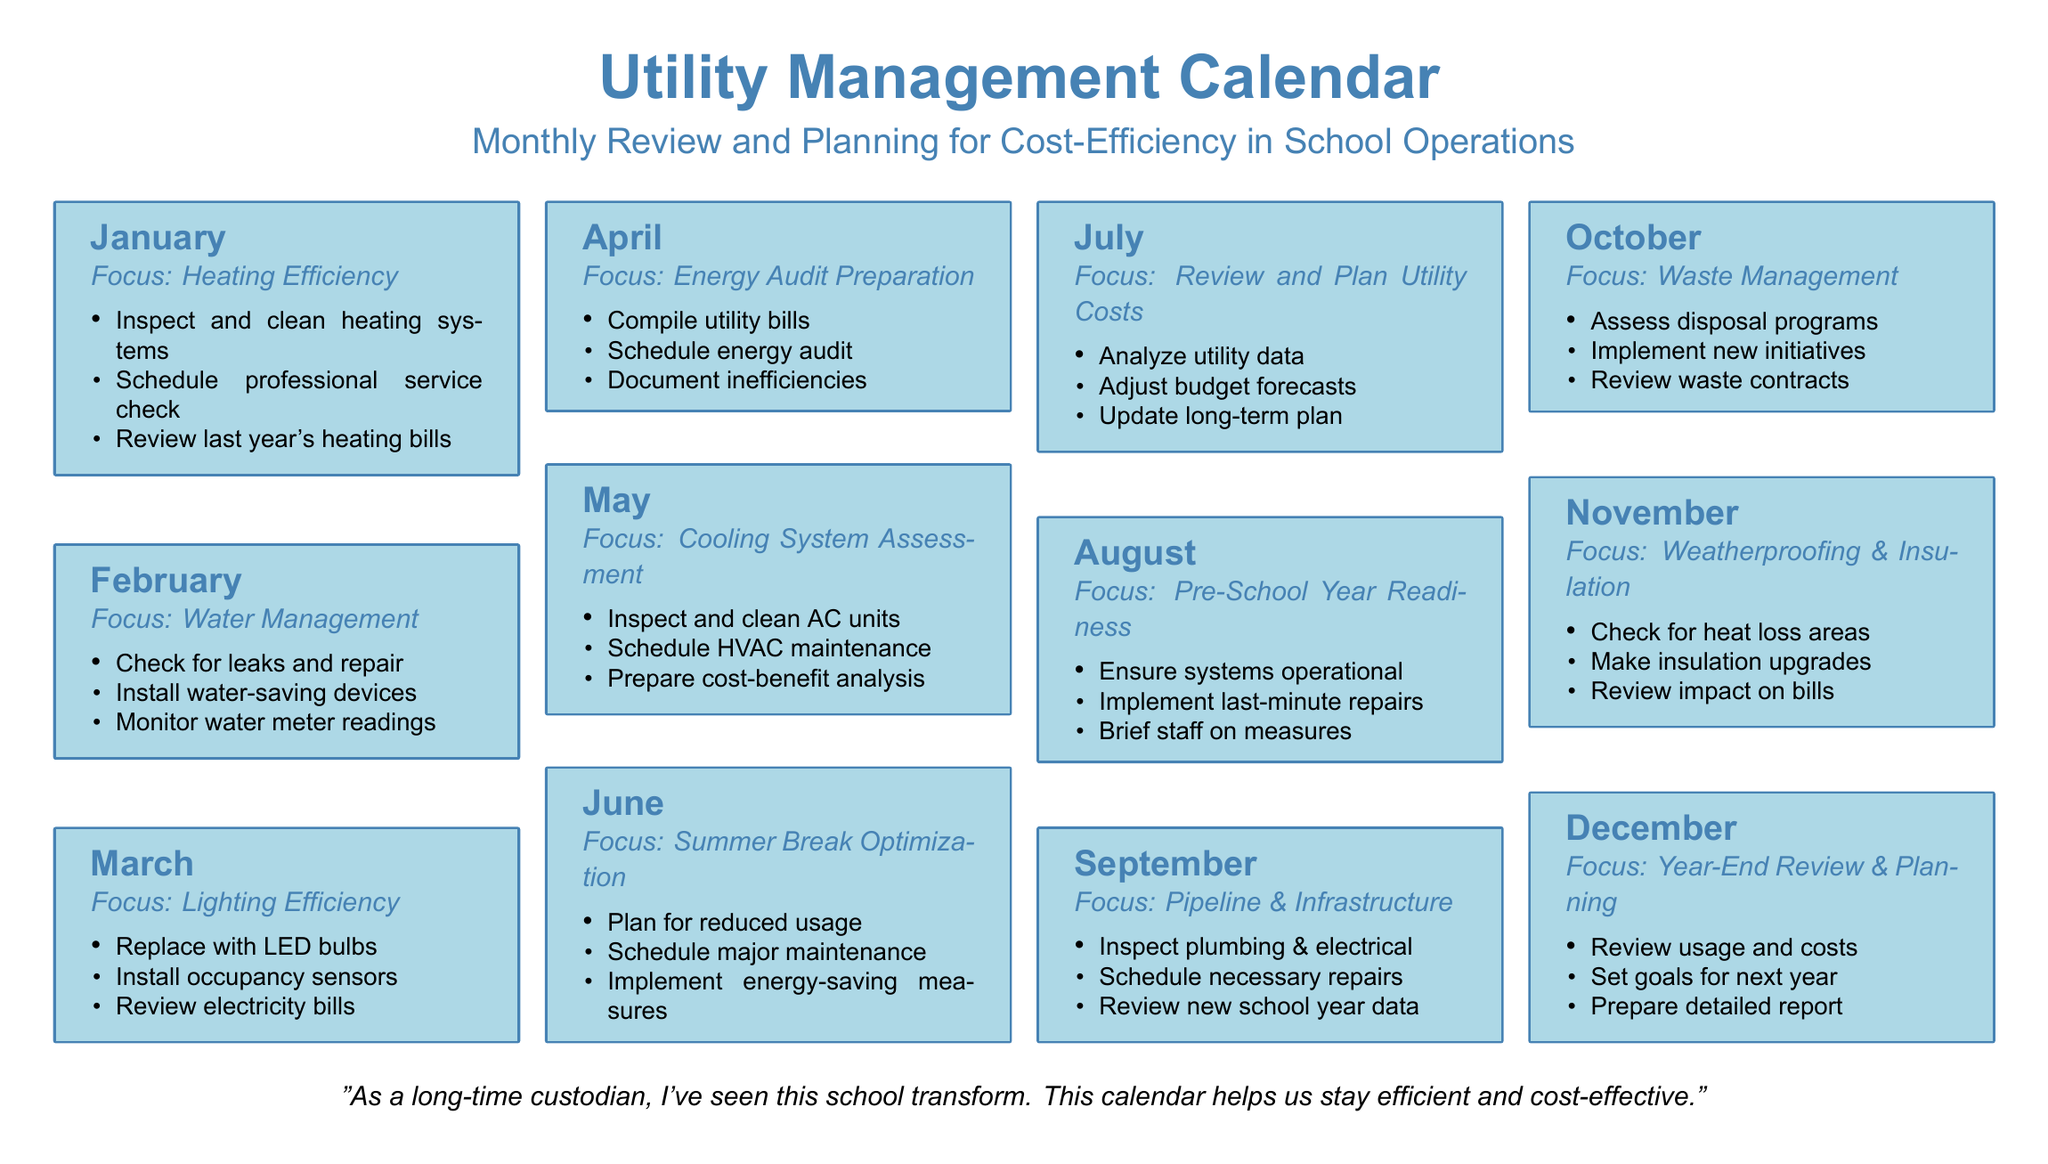What is the focus for January? The focus for January is Heating Efficiency, as stated in the calendar.
Answer: Heating Efficiency What task is scheduled for April? The task scheduled for April is to schedule an energy audit, according to the document.
Answer: Schedule energy audit How many tasks are listed for October? There are three tasks listed for October in the calendar.
Answer: Three Which month is associated with Water Management? The month associated with Water Management is February, as indicated in the document.
Answer: February What is the main focus for the month of July? The main focus for July is to Review and Plan Utility Costs, as mentioned in the calendar.
Answer: Review and Plan Utility Costs In which month should the cooling system be assessed? The cooling system should be assessed in May, based on the information provided.
Answer: May How many months are listed in the calendar? The calendar lists a total of twelve months for utility management.
Answer: Twelve What is the final task for December? The final task for December is to prepare a detailed report.
Answer: Prepare detailed report What type of devices should be installed in February? Water-saving devices should be installed in February, as highlighted in the calendar.
Answer: Water-saving devices 